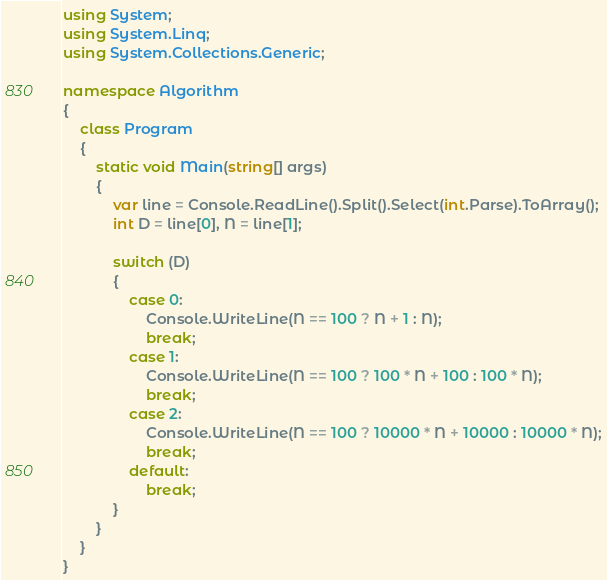Convert code to text. <code><loc_0><loc_0><loc_500><loc_500><_C#_>using System;
using System.Linq;
using System.Collections.Generic;

namespace Algorithm
{
    class Program
    {
        static void Main(string[] args)
        {
            var line = Console.ReadLine().Split().Select(int.Parse).ToArray();
            int D = line[0], N = line[1];

            switch (D)
            {
                case 0:
                    Console.WriteLine(N == 100 ? N + 1 : N);
                    break;
                case 1:
                    Console.WriteLine(N == 100 ? 100 * N + 100 : 100 * N);
                    break;
                case 2:
                    Console.WriteLine(N == 100 ? 10000 * N + 10000 : 10000 * N);
                    break;
                default:
                    break;
            }
        }
    }
}</code> 